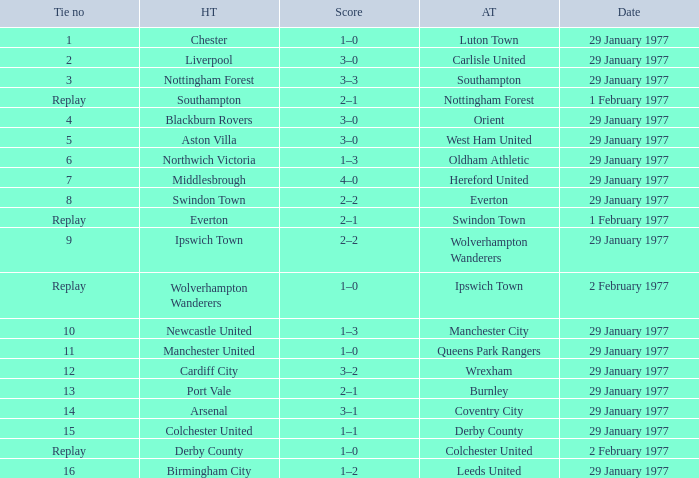What is the score in the Liverpool home game? 3–0. 